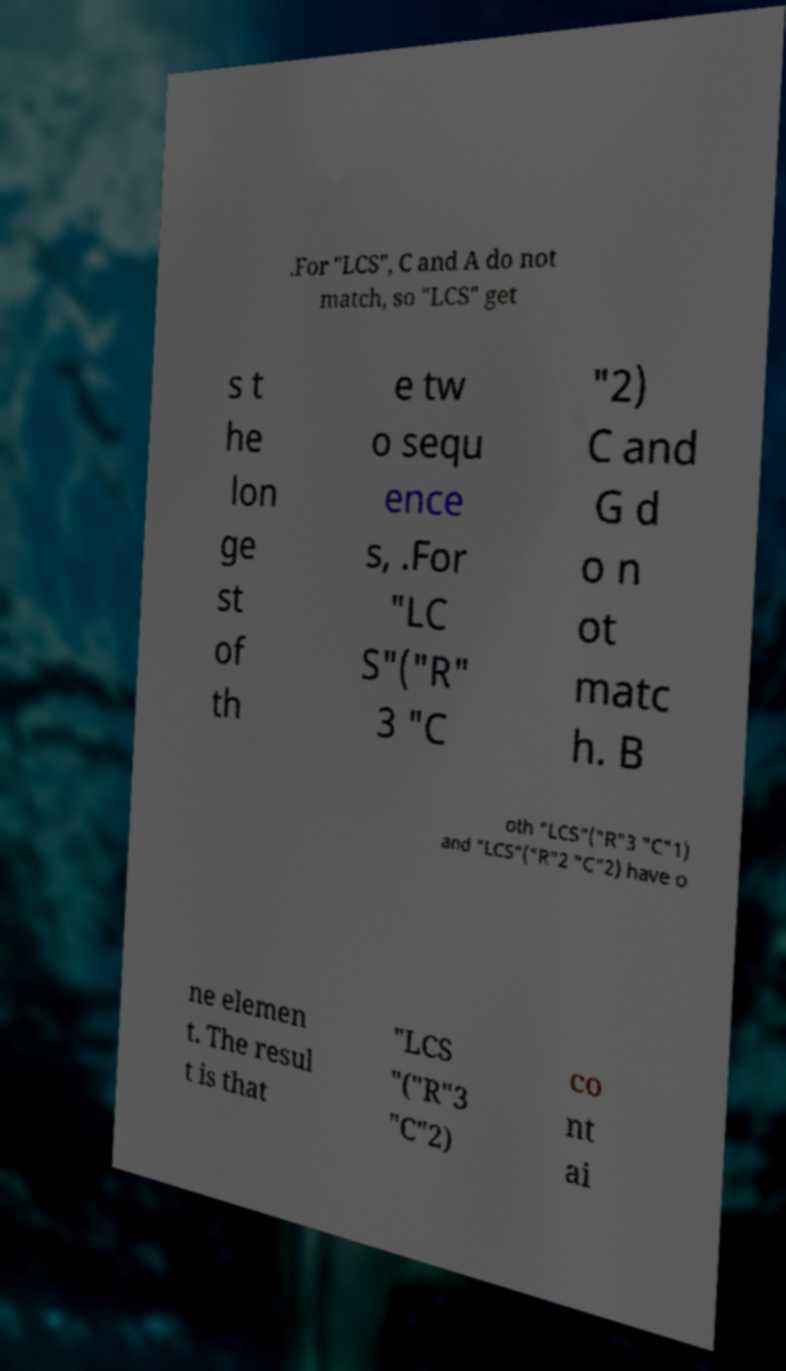Please read and relay the text visible in this image. What does it say? .For "LCS", C and A do not match, so "LCS" get s t he lon ge st of th e tw o sequ ence s, .For "LC S"("R" 3 "C "2) C and G d o n ot matc h. B oth "LCS"("R"3 "C"1) and "LCS"("R"2 "C"2) have o ne elemen t. The resul t is that "LCS "("R"3 "C"2) co nt ai 